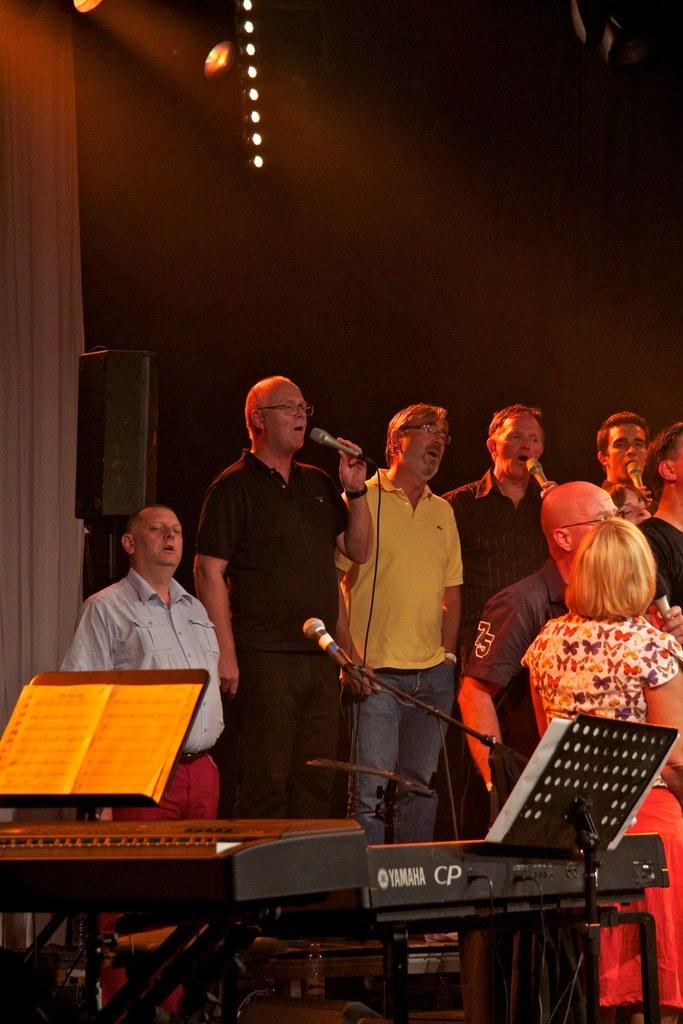<image>
Write a terse but informative summary of the picture. In front of a group of people is a yamaha keyboard. 